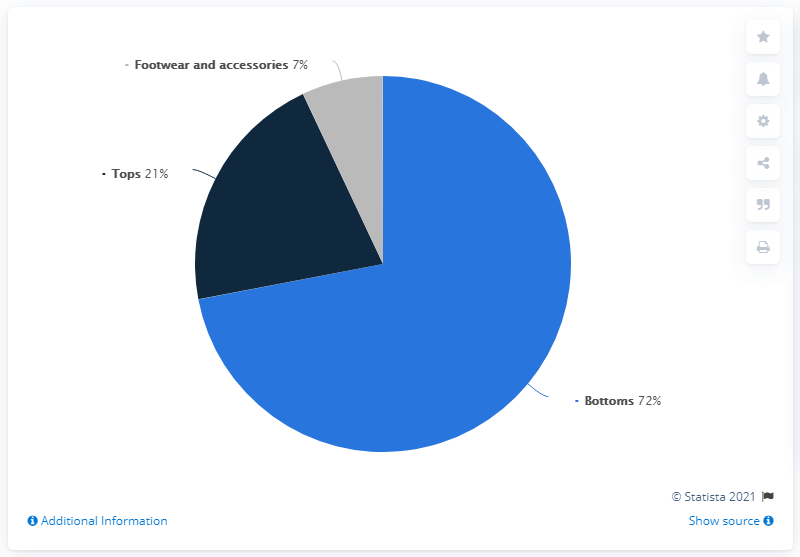Indicate a few pertinent items in this graphic. In 2019, Levi Strauss's revenue was primarily contributed by their bottoms product line, which accounted for 72% of their global revenue share. Levi Strauss' revenue in 2019 was primarily contributed by the sale of tops and footwear and accessories, which accounted for approximately 28% of the company's global revenue. 